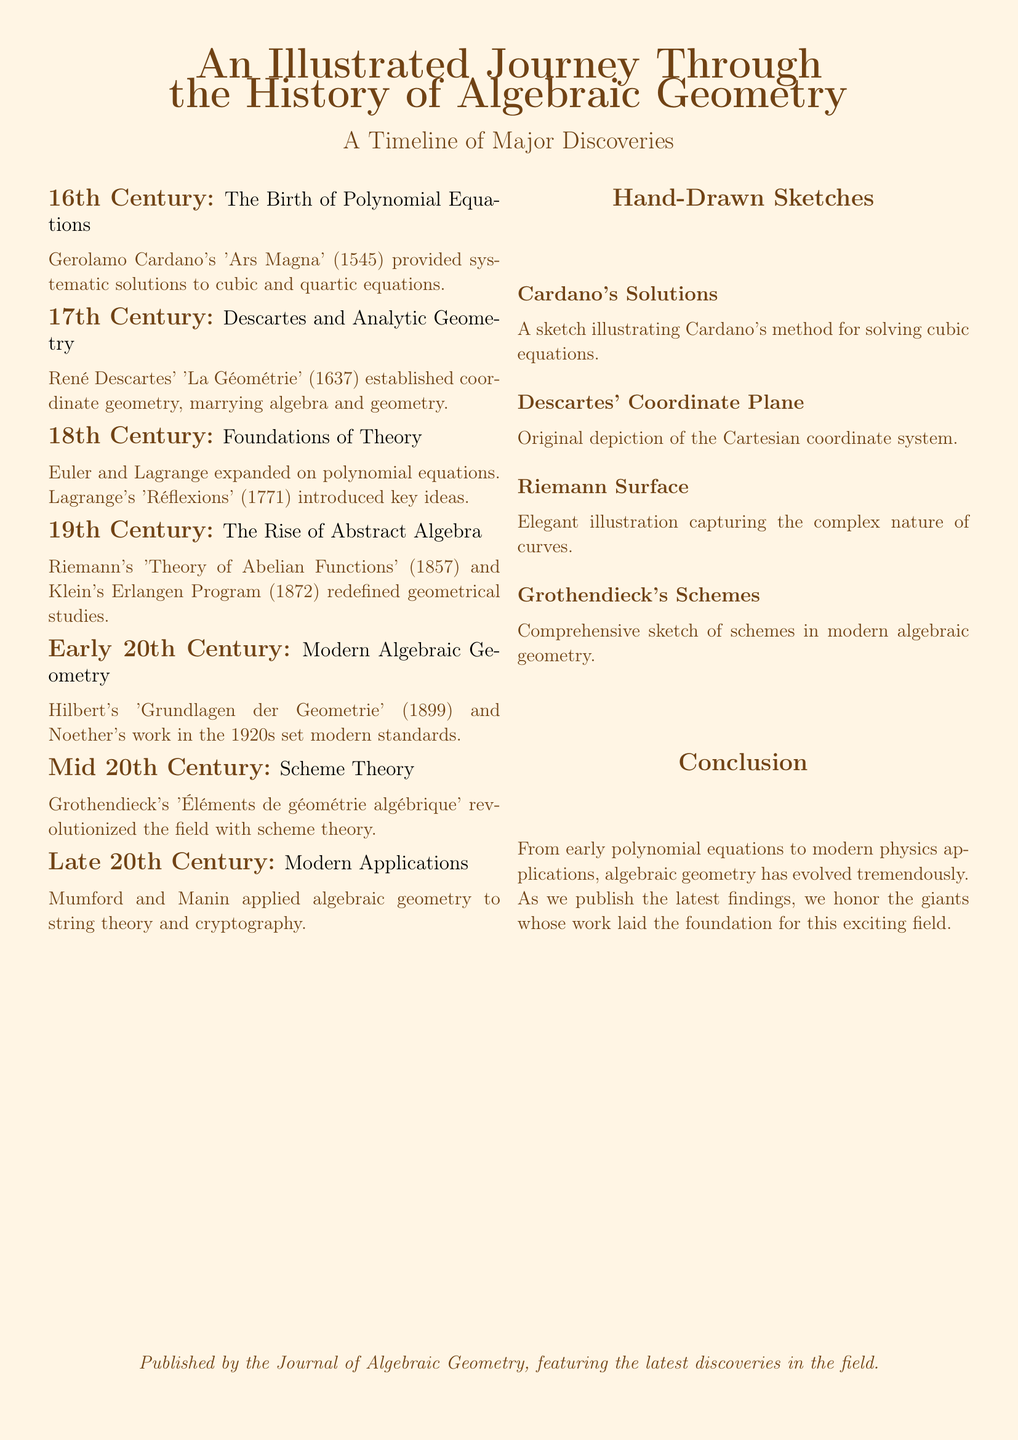What year was Cardano's 'Ars Magna' published? Cardano's 'Ars Magna' (1545) provided systematic solutions to cubic and quartic equations, thus it was published in 1545.
Answer: 1545 Who introduced key ideas in polynomial equations in the 18th century? Lagrange's 'Réflexions' (1771) introduced key ideas, indicating Lagrange's significant contribution during the 18th century.
Answer: Lagrange Which publication is associated with scheme theory? Grothendieck's 'Éléments de géométrie algébrique' revolutionized the field with scheme theory, indicating its importance in the timeline.
Answer: Éléments de géométrie algébrique What major concept did René Descartes establish? Descartes' 'La Géométrie' established coordinate geometry, marrying algebra and geometry, which highlights its foundational aspect.
Answer: Coordinate geometry In which century did Riemann publish 'Theory of Abelian Functions'? Riemann's 'Theory of Abelian Functions' was published in 1857, which falls in the 19th century.
Answer: 19th Century What is the visual representation for Cardano's methods? The document describes a sketch illustrating Cardano's method for solving cubic equations, showing its informative value.
Answer: Cardano's Solutions Which mathematician is linked with modern applications in the late 20th century? Mumford and Manin applied algebraic geometry to string theory and cryptography, indicating their contributions in that era.
Answer: Mumford and Manin What significant shift occurred in early 20th century algebraic geometry? Hilbert's 'Grundlagen der Geometrie' and Noether's work in the 1920s set modern standards, indicating a transformation in the field.
Answer: Modern standards What crucial aspect characterizes the timeline's conclusion? The conclusion summarizes the evolution from early polynomial equations to modern physics applications in algebraic geometry.
Answer: Evolution 